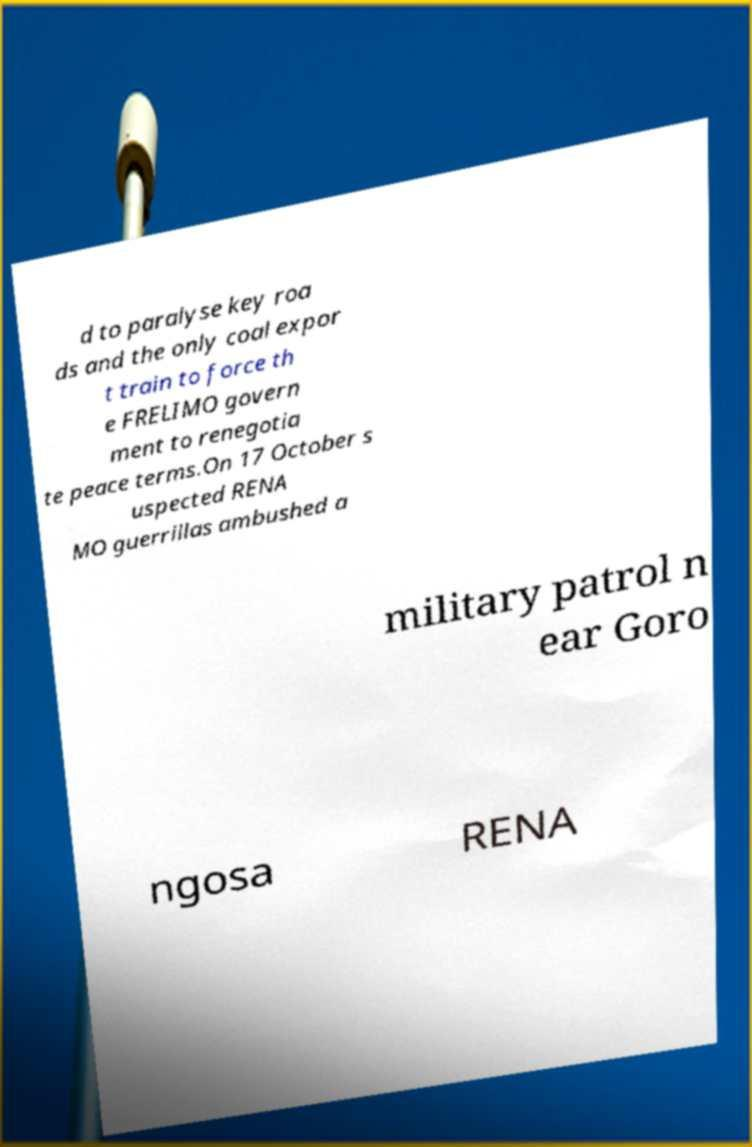Can you accurately transcribe the text from the provided image for me? d to paralyse key roa ds and the only coal expor t train to force th e FRELIMO govern ment to renegotia te peace terms.On 17 October s uspected RENA MO guerrillas ambushed a military patrol n ear Goro ngosa RENA 